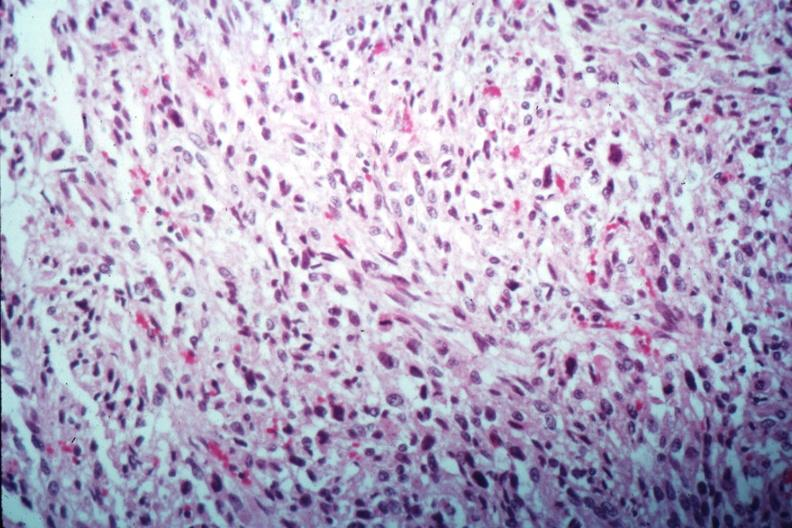where is this from?
Answer the question using a single word or phrase. Female reproductive system 